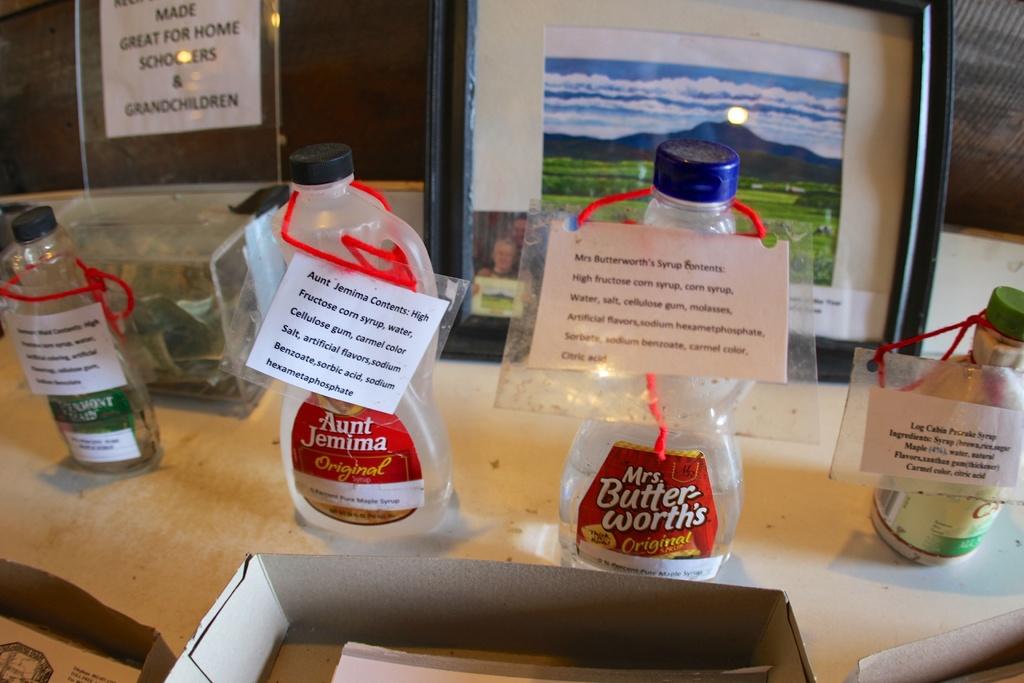What is the name of one of the syrups?
Keep it short and to the point. Mrs. butter-worth's. How many labels can you see?
Ensure brevity in your answer.  4. 